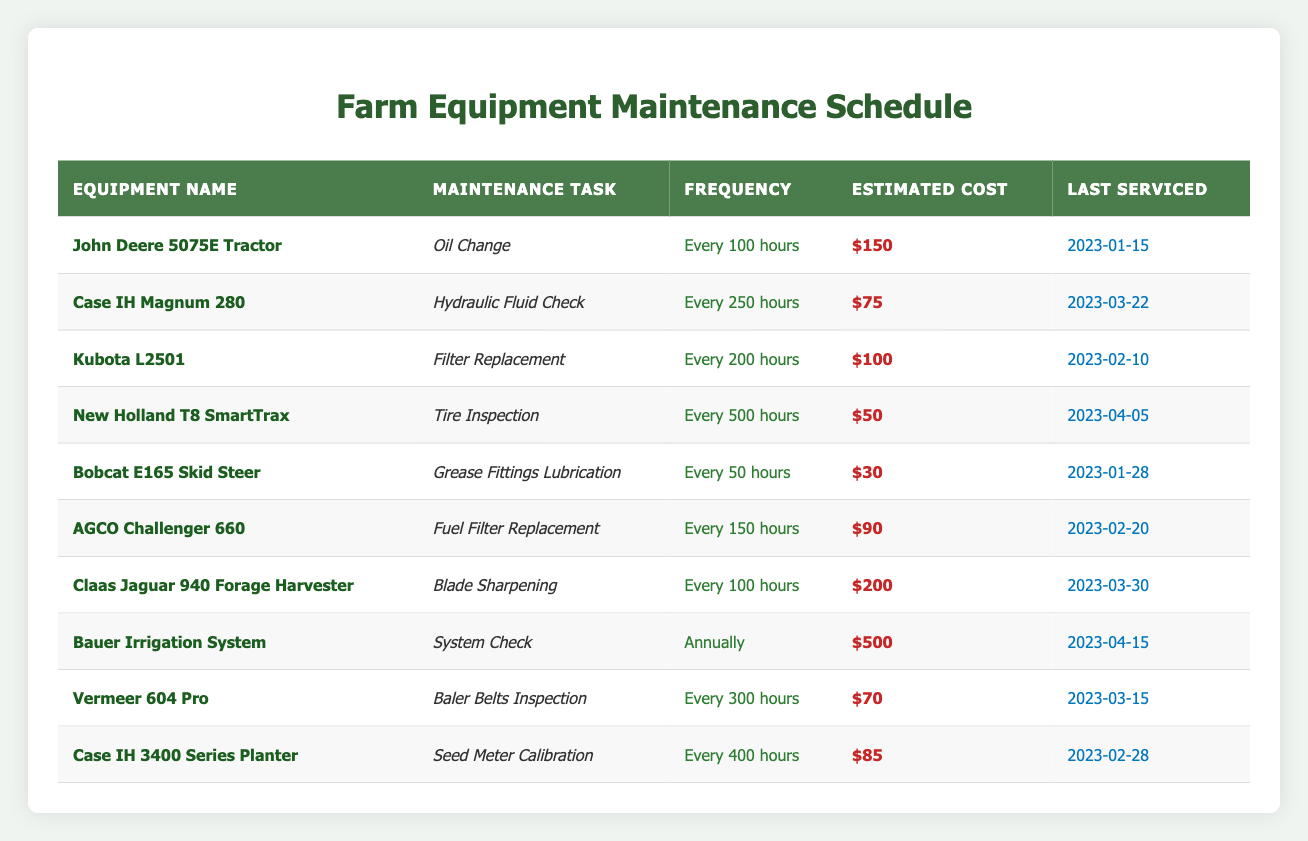What is the estimated cost of servicing the John Deere 5075E Tractor? The table shows that the estimated cost for an oil change on the John Deere 5075E Tractor is **$150**.
Answer: $150 How often should the hydraulic fluid check be performed on the Case IH Magnum 280? The frequency for the hydraulic fluid check on the Case IH Magnum 280 is specified in the table as **Every 250 hours**.
Answer: Every 250 hours Which equipment has the highest estimated cost for maintenance? Upon reviewing the estimated costs, the Claas Jaguar 940 Forage Harvester has the highest estimated cost of **$200** for blade sharpening.
Answer: $200 When was the last servicing date for the Bobcat E165 Skid Steer? The last serviced date for the Bobcat E165 Skid Steer is given in the table as **2023-01-28**.
Answer: 2023-01-28 Is there any equipment that requires maintenance on a monthly basis? The table indicates that there is no equipment listed that requires maintenance on a monthly basis; the closest frequency is **Every 50 hours** for the Bobcat E165 Skid Steer.
Answer: No How much is the total estimated cost of servicing the equipment that requires maintenance every 100 hours? The equipment requiring maintenance every 100 hours are the John Deere 5075E Tractor and the Claas Jaguar 940 Forage Harvester. Their costs are $150 and $200 respectively. Adding them gives $150 + $200 = $350.
Answer: $350 What is the average maintenance cost for the equipment that is serviced annually? The only equipment with annual servicing is the Bauer Irrigation System, which has a maintenance cost of **$500**. Since there is only one data point, the average is also $500.
Answer: $500 Which equipment needs maintenance most frequently and what is the task? The Bobcat E165 Skid Steer requires maintenance the most frequently, every **50 hours**, for the task of Grease Fittings Lubrication.
Answer: Bobcat E165 Skid Steer, Grease Fittings Lubrication What is the relationship between the maintenance frequency and the last serviced dates? By analyzing the last serviced dates, we see that equipment with shorter frequencies (like every 50 or 100 hours) are serviced more often than those with longer frequencies (like annually), demonstrating a direct correlation that frequent maintenance tasks occur more regularly.
Answer: Direct correlation Which piece of equipment requires the lowest maintenance cost and what task does it perform? The lowest maintenance cost is **$30** for the Bobcat E165 Skid Steer, which requires Grease Fittings Lubrication.
Answer: Bobcat E165 Skid Steer, Grease Fittings Lubrication 